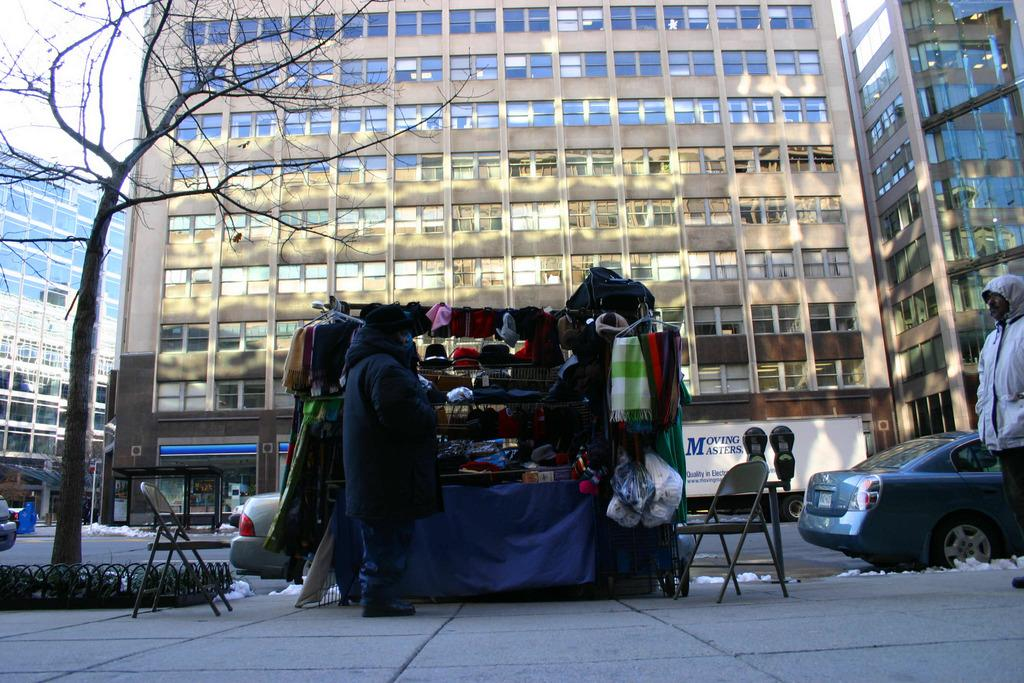What can be seen on the road in the image? There are vehicles on the road in the image. What type of structures are visible in the image? There are buildings with windows in the image. What type of furniture is present in the image? Chairs are present in the image. What are the two people doing in the image? Two people are standing on a platform in the image. What type of clothing is visible in the image? Caps are visible in the image. What type of vegetation is present in the image? There is a tree in the image. What is visible in the background of the image? The sky is visible in the background of the image. How many cattle are grazing in the cellar in the image? There are no cattle or cellars present in the image. What type of paper is being used by the people standing on the platform in the image? There is no paper visible in the image; only caps and chairs are mentioned. 